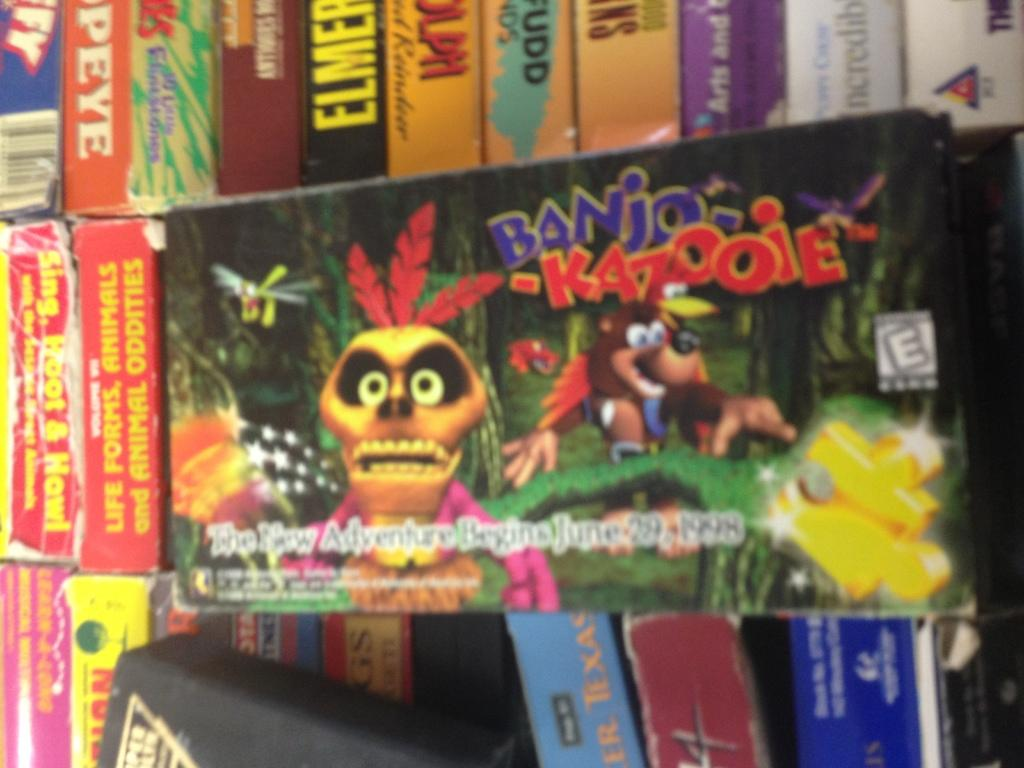<image>
Give a short and clear explanation of the subsequent image. Next to tattered and torn items an Old Banjo and Kazooie game is placed front and center. 